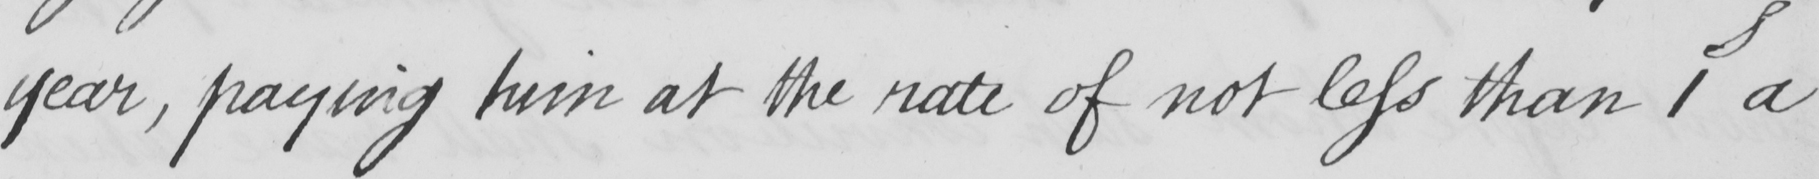Please transcribe the handwritten text in this image. year , paying him at the rate of not less than 1s a 